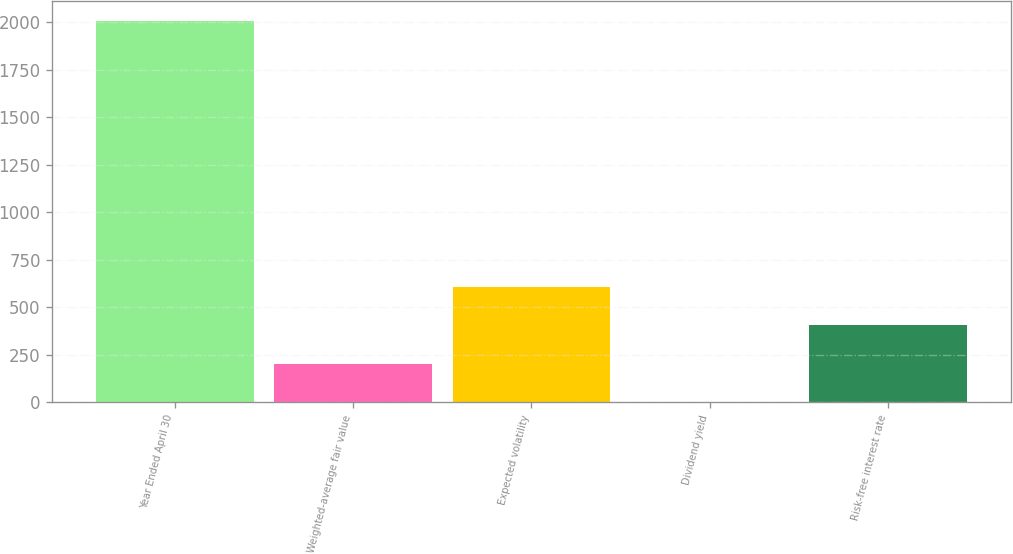<chart> <loc_0><loc_0><loc_500><loc_500><bar_chart><fcel>Year Ended April 30<fcel>Weighted-average fair value<fcel>Expected volatility<fcel>Dividend yield<fcel>Risk-free interest rate<nl><fcel>2008<fcel>203<fcel>604.12<fcel>2.44<fcel>403.56<nl></chart> 